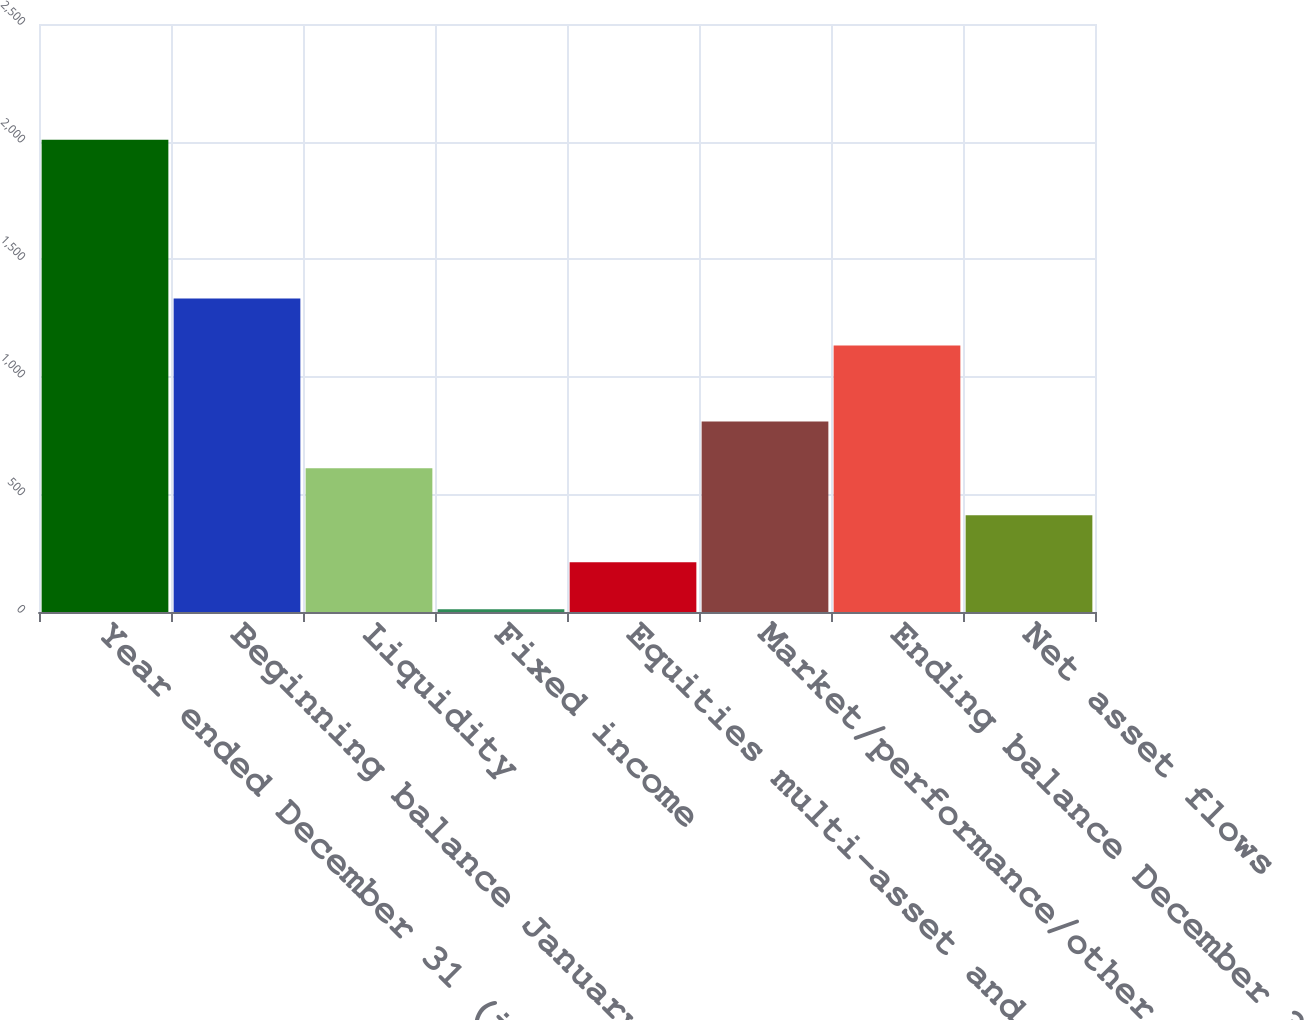Convert chart to OTSL. <chart><loc_0><loc_0><loc_500><loc_500><bar_chart><fcel>Year ended December 31 (in<fcel>Beginning balance January 1<fcel>Liquidity<fcel>Fixed income<fcel>Equities multi-asset and<fcel>Market/performance/other<fcel>Ending balance December 31<fcel>Net asset flows<nl><fcel>2008<fcel>1332.6<fcel>610.8<fcel>12<fcel>211.6<fcel>810.4<fcel>1133<fcel>411.2<nl></chart> 